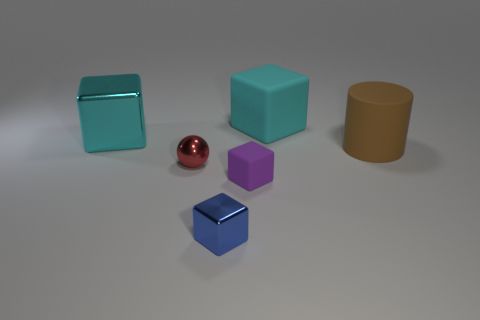Subtract all big metallic blocks. How many blocks are left? 3 Add 1 tiny blue blocks. How many objects exist? 7 Subtract all gray cylinders. How many cyan cubes are left? 2 Subtract all blue cubes. How many cubes are left? 3 Subtract 1 blocks. How many blocks are left? 3 Subtract all balls. How many objects are left? 5 Add 6 cyan things. How many cyan things are left? 8 Add 6 large cyan objects. How many large cyan objects exist? 8 Subtract 0 gray balls. How many objects are left? 6 Subtract all purple cylinders. Subtract all green balls. How many cylinders are left? 1 